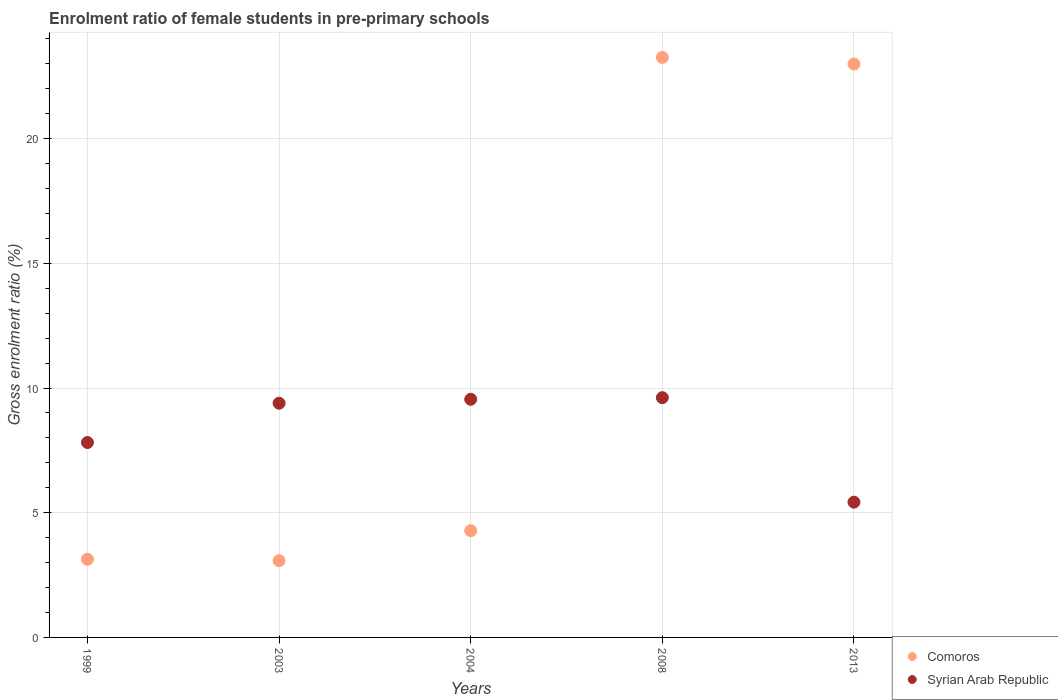How many different coloured dotlines are there?
Offer a very short reply. 2. Is the number of dotlines equal to the number of legend labels?
Provide a short and direct response. Yes. What is the enrolment ratio of female students in pre-primary schools in Syrian Arab Republic in 2013?
Ensure brevity in your answer.  5.42. Across all years, what is the maximum enrolment ratio of female students in pre-primary schools in Comoros?
Make the answer very short. 23.26. Across all years, what is the minimum enrolment ratio of female students in pre-primary schools in Comoros?
Ensure brevity in your answer.  3.08. In which year was the enrolment ratio of female students in pre-primary schools in Comoros maximum?
Provide a short and direct response. 2008. What is the total enrolment ratio of female students in pre-primary schools in Comoros in the graph?
Your answer should be very brief. 56.75. What is the difference between the enrolment ratio of female students in pre-primary schools in Syrian Arab Republic in 2003 and that in 2008?
Give a very brief answer. -0.22. What is the difference between the enrolment ratio of female students in pre-primary schools in Comoros in 1999 and the enrolment ratio of female students in pre-primary schools in Syrian Arab Republic in 2008?
Give a very brief answer. -6.48. What is the average enrolment ratio of female students in pre-primary schools in Comoros per year?
Make the answer very short. 11.35. In the year 2003, what is the difference between the enrolment ratio of female students in pre-primary schools in Syrian Arab Republic and enrolment ratio of female students in pre-primary schools in Comoros?
Keep it short and to the point. 6.31. In how many years, is the enrolment ratio of female students in pre-primary schools in Syrian Arab Republic greater than 19 %?
Provide a succinct answer. 0. What is the ratio of the enrolment ratio of female students in pre-primary schools in Comoros in 1999 to that in 2013?
Your answer should be compact. 0.14. Is the difference between the enrolment ratio of female students in pre-primary schools in Syrian Arab Republic in 2003 and 2004 greater than the difference between the enrolment ratio of female students in pre-primary schools in Comoros in 2003 and 2004?
Provide a short and direct response. Yes. What is the difference between the highest and the second highest enrolment ratio of female students in pre-primary schools in Syrian Arab Republic?
Your response must be concise. 0.06. What is the difference between the highest and the lowest enrolment ratio of female students in pre-primary schools in Comoros?
Provide a short and direct response. 20.18. Is the sum of the enrolment ratio of female students in pre-primary schools in Comoros in 2003 and 2008 greater than the maximum enrolment ratio of female students in pre-primary schools in Syrian Arab Republic across all years?
Offer a terse response. Yes. Does the enrolment ratio of female students in pre-primary schools in Syrian Arab Republic monotonically increase over the years?
Provide a short and direct response. No. Is the enrolment ratio of female students in pre-primary schools in Syrian Arab Republic strictly greater than the enrolment ratio of female students in pre-primary schools in Comoros over the years?
Your response must be concise. No. Is the enrolment ratio of female students in pre-primary schools in Comoros strictly less than the enrolment ratio of female students in pre-primary schools in Syrian Arab Republic over the years?
Provide a short and direct response. No. How many years are there in the graph?
Offer a terse response. 5. What is the difference between two consecutive major ticks on the Y-axis?
Provide a succinct answer. 5. Does the graph contain any zero values?
Ensure brevity in your answer.  No. Does the graph contain grids?
Offer a terse response. Yes. How many legend labels are there?
Ensure brevity in your answer.  2. How are the legend labels stacked?
Your answer should be very brief. Vertical. What is the title of the graph?
Your response must be concise. Enrolment ratio of female students in pre-primary schools. What is the label or title of the X-axis?
Make the answer very short. Years. What is the Gross enrolment ratio (%) of Comoros in 1999?
Provide a succinct answer. 3.13. What is the Gross enrolment ratio (%) in Syrian Arab Republic in 1999?
Offer a very short reply. 7.82. What is the Gross enrolment ratio (%) in Comoros in 2003?
Offer a very short reply. 3.08. What is the Gross enrolment ratio (%) of Syrian Arab Republic in 2003?
Keep it short and to the point. 9.39. What is the Gross enrolment ratio (%) in Comoros in 2004?
Keep it short and to the point. 4.28. What is the Gross enrolment ratio (%) of Syrian Arab Republic in 2004?
Offer a terse response. 9.55. What is the Gross enrolment ratio (%) of Comoros in 2008?
Keep it short and to the point. 23.26. What is the Gross enrolment ratio (%) of Syrian Arab Republic in 2008?
Give a very brief answer. 9.61. What is the Gross enrolment ratio (%) of Comoros in 2013?
Provide a succinct answer. 22.99. What is the Gross enrolment ratio (%) of Syrian Arab Republic in 2013?
Ensure brevity in your answer.  5.42. Across all years, what is the maximum Gross enrolment ratio (%) in Comoros?
Keep it short and to the point. 23.26. Across all years, what is the maximum Gross enrolment ratio (%) of Syrian Arab Republic?
Your answer should be very brief. 9.61. Across all years, what is the minimum Gross enrolment ratio (%) of Comoros?
Offer a very short reply. 3.08. Across all years, what is the minimum Gross enrolment ratio (%) in Syrian Arab Republic?
Keep it short and to the point. 5.42. What is the total Gross enrolment ratio (%) of Comoros in the graph?
Provide a short and direct response. 56.75. What is the total Gross enrolment ratio (%) in Syrian Arab Republic in the graph?
Your answer should be very brief. 41.8. What is the difference between the Gross enrolment ratio (%) of Comoros in 1999 and that in 2003?
Provide a succinct answer. 0.06. What is the difference between the Gross enrolment ratio (%) of Syrian Arab Republic in 1999 and that in 2003?
Your response must be concise. -1.57. What is the difference between the Gross enrolment ratio (%) of Comoros in 1999 and that in 2004?
Your response must be concise. -1.15. What is the difference between the Gross enrolment ratio (%) of Syrian Arab Republic in 1999 and that in 2004?
Your response must be concise. -1.73. What is the difference between the Gross enrolment ratio (%) of Comoros in 1999 and that in 2008?
Provide a short and direct response. -20.12. What is the difference between the Gross enrolment ratio (%) of Syrian Arab Republic in 1999 and that in 2008?
Provide a succinct answer. -1.8. What is the difference between the Gross enrolment ratio (%) of Comoros in 1999 and that in 2013?
Offer a very short reply. -19.86. What is the difference between the Gross enrolment ratio (%) in Syrian Arab Republic in 1999 and that in 2013?
Provide a short and direct response. 2.39. What is the difference between the Gross enrolment ratio (%) of Comoros in 2003 and that in 2004?
Ensure brevity in your answer.  -1.2. What is the difference between the Gross enrolment ratio (%) of Syrian Arab Republic in 2003 and that in 2004?
Offer a terse response. -0.16. What is the difference between the Gross enrolment ratio (%) in Comoros in 2003 and that in 2008?
Give a very brief answer. -20.18. What is the difference between the Gross enrolment ratio (%) in Syrian Arab Republic in 2003 and that in 2008?
Provide a short and direct response. -0.22. What is the difference between the Gross enrolment ratio (%) in Comoros in 2003 and that in 2013?
Your answer should be compact. -19.91. What is the difference between the Gross enrolment ratio (%) of Syrian Arab Republic in 2003 and that in 2013?
Offer a terse response. 3.97. What is the difference between the Gross enrolment ratio (%) of Comoros in 2004 and that in 2008?
Your answer should be compact. -18.98. What is the difference between the Gross enrolment ratio (%) in Syrian Arab Republic in 2004 and that in 2008?
Ensure brevity in your answer.  -0.06. What is the difference between the Gross enrolment ratio (%) of Comoros in 2004 and that in 2013?
Offer a terse response. -18.71. What is the difference between the Gross enrolment ratio (%) of Syrian Arab Republic in 2004 and that in 2013?
Make the answer very short. 4.13. What is the difference between the Gross enrolment ratio (%) of Comoros in 2008 and that in 2013?
Make the answer very short. 0.27. What is the difference between the Gross enrolment ratio (%) of Syrian Arab Republic in 2008 and that in 2013?
Offer a very short reply. 4.19. What is the difference between the Gross enrolment ratio (%) in Comoros in 1999 and the Gross enrolment ratio (%) in Syrian Arab Republic in 2003?
Keep it short and to the point. -6.26. What is the difference between the Gross enrolment ratio (%) in Comoros in 1999 and the Gross enrolment ratio (%) in Syrian Arab Republic in 2004?
Offer a terse response. -6.42. What is the difference between the Gross enrolment ratio (%) of Comoros in 1999 and the Gross enrolment ratio (%) of Syrian Arab Republic in 2008?
Your answer should be compact. -6.48. What is the difference between the Gross enrolment ratio (%) of Comoros in 1999 and the Gross enrolment ratio (%) of Syrian Arab Republic in 2013?
Provide a succinct answer. -2.29. What is the difference between the Gross enrolment ratio (%) of Comoros in 2003 and the Gross enrolment ratio (%) of Syrian Arab Republic in 2004?
Provide a short and direct response. -6.47. What is the difference between the Gross enrolment ratio (%) in Comoros in 2003 and the Gross enrolment ratio (%) in Syrian Arab Republic in 2008?
Provide a succinct answer. -6.54. What is the difference between the Gross enrolment ratio (%) of Comoros in 2003 and the Gross enrolment ratio (%) of Syrian Arab Republic in 2013?
Your response must be concise. -2.35. What is the difference between the Gross enrolment ratio (%) in Comoros in 2004 and the Gross enrolment ratio (%) in Syrian Arab Republic in 2008?
Provide a succinct answer. -5.33. What is the difference between the Gross enrolment ratio (%) of Comoros in 2004 and the Gross enrolment ratio (%) of Syrian Arab Republic in 2013?
Give a very brief answer. -1.14. What is the difference between the Gross enrolment ratio (%) of Comoros in 2008 and the Gross enrolment ratio (%) of Syrian Arab Republic in 2013?
Provide a short and direct response. 17.84. What is the average Gross enrolment ratio (%) in Comoros per year?
Make the answer very short. 11.35. What is the average Gross enrolment ratio (%) of Syrian Arab Republic per year?
Ensure brevity in your answer.  8.36. In the year 1999, what is the difference between the Gross enrolment ratio (%) of Comoros and Gross enrolment ratio (%) of Syrian Arab Republic?
Ensure brevity in your answer.  -4.68. In the year 2003, what is the difference between the Gross enrolment ratio (%) of Comoros and Gross enrolment ratio (%) of Syrian Arab Republic?
Your answer should be very brief. -6.31. In the year 2004, what is the difference between the Gross enrolment ratio (%) in Comoros and Gross enrolment ratio (%) in Syrian Arab Republic?
Your response must be concise. -5.27. In the year 2008, what is the difference between the Gross enrolment ratio (%) in Comoros and Gross enrolment ratio (%) in Syrian Arab Republic?
Your answer should be compact. 13.64. In the year 2013, what is the difference between the Gross enrolment ratio (%) of Comoros and Gross enrolment ratio (%) of Syrian Arab Republic?
Provide a succinct answer. 17.57. What is the ratio of the Gross enrolment ratio (%) of Comoros in 1999 to that in 2003?
Offer a terse response. 1.02. What is the ratio of the Gross enrolment ratio (%) of Syrian Arab Republic in 1999 to that in 2003?
Your answer should be compact. 0.83. What is the ratio of the Gross enrolment ratio (%) of Comoros in 1999 to that in 2004?
Make the answer very short. 0.73. What is the ratio of the Gross enrolment ratio (%) in Syrian Arab Republic in 1999 to that in 2004?
Your answer should be compact. 0.82. What is the ratio of the Gross enrolment ratio (%) in Comoros in 1999 to that in 2008?
Keep it short and to the point. 0.13. What is the ratio of the Gross enrolment ratio (%) in Syrian Arab Republic in 1999 to that in 2008?
Your answer should be very brief. 0.81. What is the ratio of the Gross enrolment ratio (%) of Comoros in 1999 to that in 2013?
Give a very brief answer. 0.14. What is the ratio of the Gross enrolment ratio (%) of Syrian Arab Republic in 1999 to that in 2013?
Your answer should be very brief. 1.44. What is the ratio of the Gross enrolment ratio (%) of Comoros in 2003 to that in 2004?
Provide a succinct answer. 0.72. What is the ratio of the Gross enrolment ratio (%) of Syrian Arab Republic in 2003 to that in 2004?
Your answer should be very brief. 0.98. What is the ratio of the Gross enrolment ratio (%) in Comoros in 2003 to that in 2008?
Your answer should be very brief. 0.13. What is the ratio of the Gross enrolment ratio (%) in Syrian Arab Republic in 2003 to that in 2008?
Your answer should be compact. 0.98. What is the ratio of the Gross enrolment ratio (%) of Comoros in 2003 to that in 2013?
Ensure brevity in your answer.  0.13. What is the ratio of the Gross enrolment ratio (%) in Syrian Arab Republic in 2003 to that in 2013?
Make the answer very short. 1.73. What is the ratio of the Gross enrolment ratio (%) in Comoros in 2004 to that in 2008?
Your answer should be very brief. 0.18. What is the ratio of the Gross enrolment ratio (%) of Syrian Arab Republic in 2004 to that in 2008?
Make the answer very short. 0.99. What is the ratio of the Gross enrolment ratio (%) of Comoros in 2004 to that in 2013?
Provide a succinct answer. 0.19. What is the ratio of the Gross enrolment ratio (%) of Syrian Arab Republic in 2004 to that in 2013?
Offer a very short reply. 1.76. What is the ratio of the Gross enrolment ratio (%) of Comoros in 2008 to that in 2013?
Your answer should be compact. 1.01. What is the ratio of the Gross enrolment ratio (%) of Syrian Arab Republic in 2008 to that in 2013?
Ensure brevity in your answer.  1.77. What is the difference between the highest and the second highest Gross enrolment ratio (%) in Comoros?
Offer a very short reply. 0.27. What is the difference between the highest and the second highest Gross enrolment ratio (%) in Syrian Arab Republic?
Your response must be concise. 0.06. What is the difference between the highest and the lowest Gross enrolment ratio (%) of Comoros?
Keep it short and to the point. 20.18. What is the difference between the highest and the lowest Gross enrolment ratio (%) of Syrian Arab Republic?
Your answer should be very brief. 4.19. 